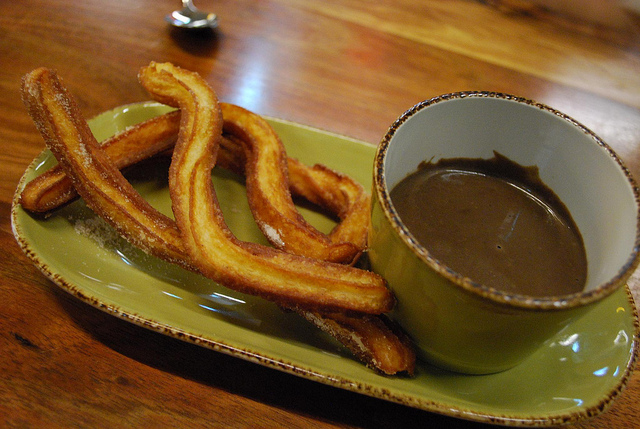What is in the mug? The mug contains a rich and thick chocolate, ideal for dipping churros. 